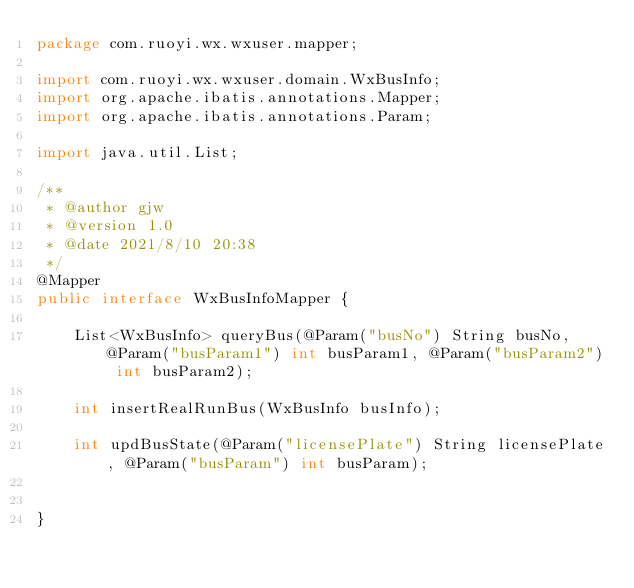<code> <loc_0><loc_0><loc_500><loc_500><_Java_>package com.ruoyi.wx.wxuser.mapper;

import com.ruoyi.wx.wxuser.domain.WxBusInfo;
import org.apache.ibatis.annotations.Mapper;
import org.apache.ibatis.annotations.Param;

import java.util.List;

/**
 * @author gjw
 * @version 1.0
 * @date 2021/8/10 20:38
 */
@Mapper
public interface WxBusInfoMapper {

    List<WxBusInfo> queryBus(@Param("busNo") String busNo, @Param("busParam1") int busParam1, @Param("busParam2") int busParam2);

    int insertRealRunBus(WxBusInfo busInfo);

    int updBusState(@Param("licensePlate") String licensePlate, @Param("busParam") int busParam);


}
</code> 